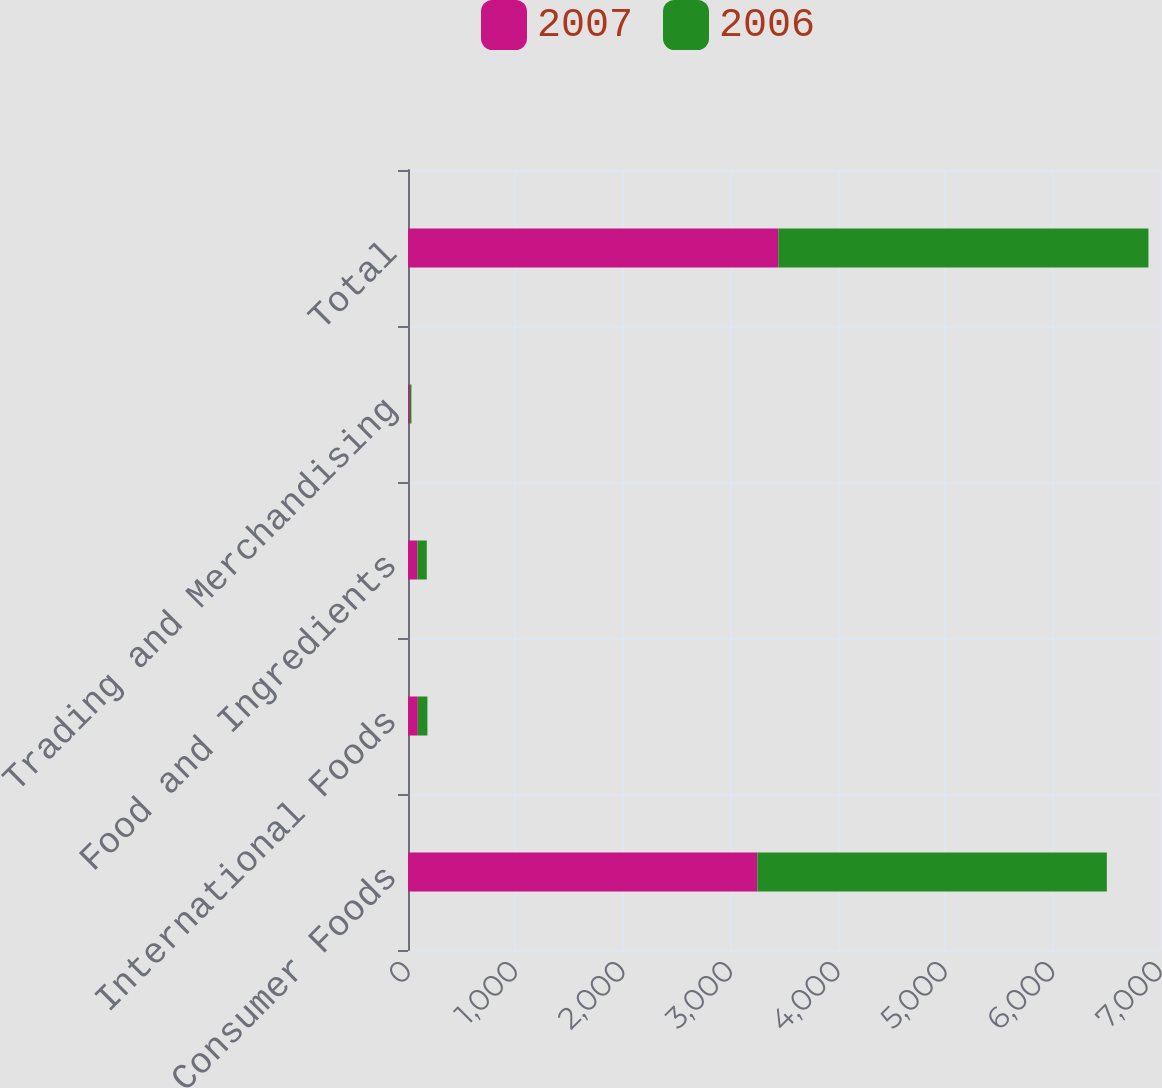Convert chart. <chart><loc_0><loc_0><loc_500><loc_500><stacked_bar_chart><ecel><fcel>Consumer Foods<fcel>International Foods<fcel>Food and Ingredients<fcel>Trading and Merchandising<fcel>Total<nl><fcel>2007<fcel>3252.1<fcel>91.3<fcel>87.6<fcel>15.9<fcel>3446.9<nl><fcel>2006<fcel>3253<fcel>89.4<fcel>87.3<fcel>15.9<fcel>3445.6<nl></chart> 